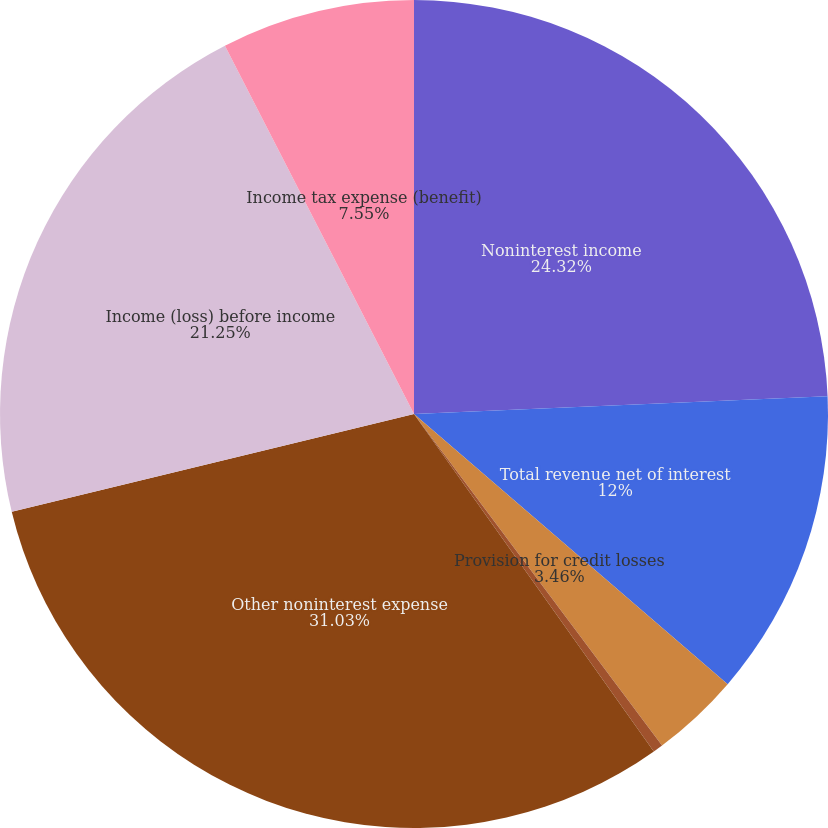Convert chart to OTSL. <chart><loc_0><loc_0><loc_500><loc_500><pie_chart><fcel>Noninterest income<fcel>Total revenue net of interest<fcel>Provision for credit losses<fcel>Amortization of intangibles<fcel>Other noninterest expense<fcel>Income (loss) before income<fcel>Income tax expense (benefit)<nl><fcel>24.32%<fcel>12.0%<fcel>3.46%<fcel>0.39%<fcel>31.04%<fcel>21.25%<fcel>7.55%<nl></chart> 